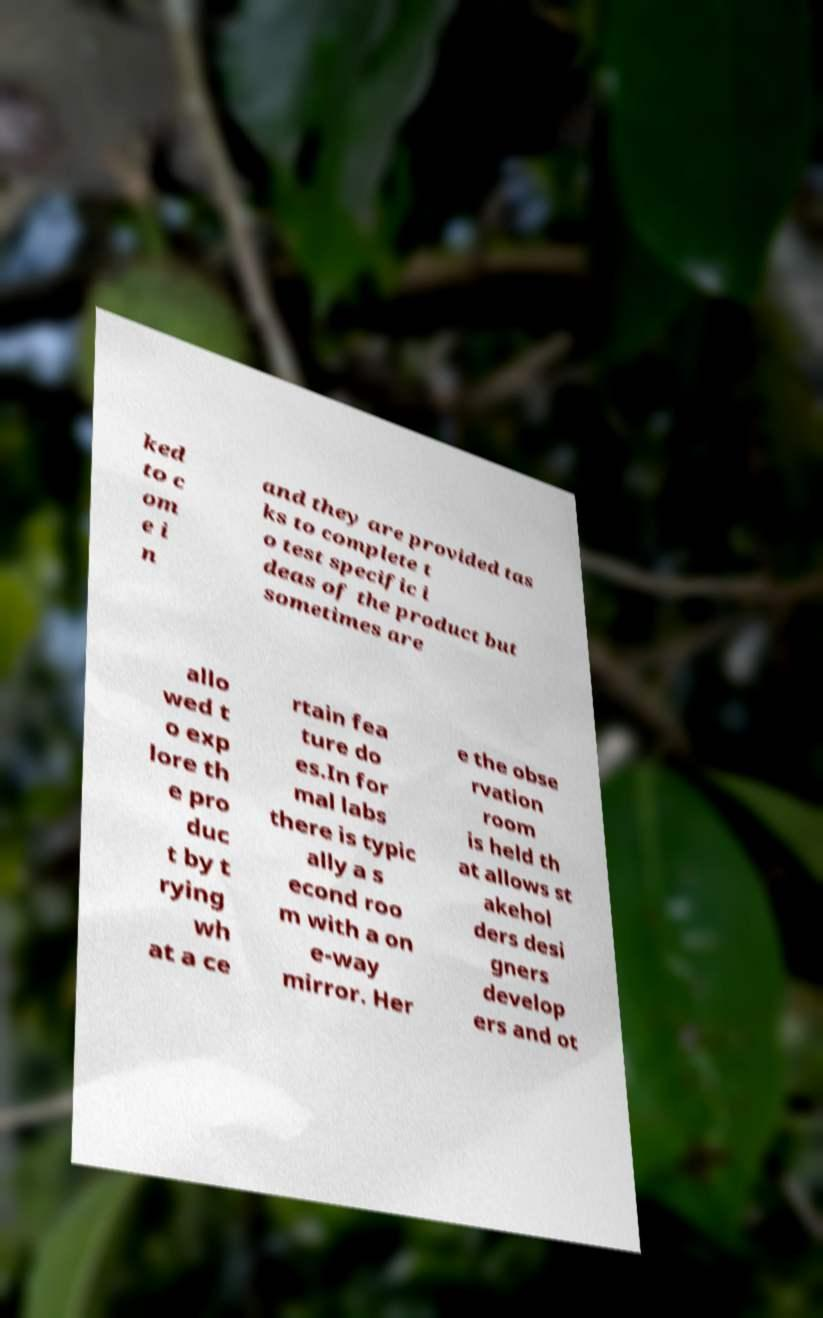I need the written content from this picture converted into text. Can you do that? ked to c om e i n and they are provided tas ks to complete t o test specific i deas of the product but sometimes are allo wed t o exp lore th e pro duc t by t rying wh at a ce rtain fea ture do es.In for mal labs there is typic ally a s econd roo m with a on e-way mirror. Her e the obse rvation room is held th at allows st akehol ders desi gners develop ers and ot 